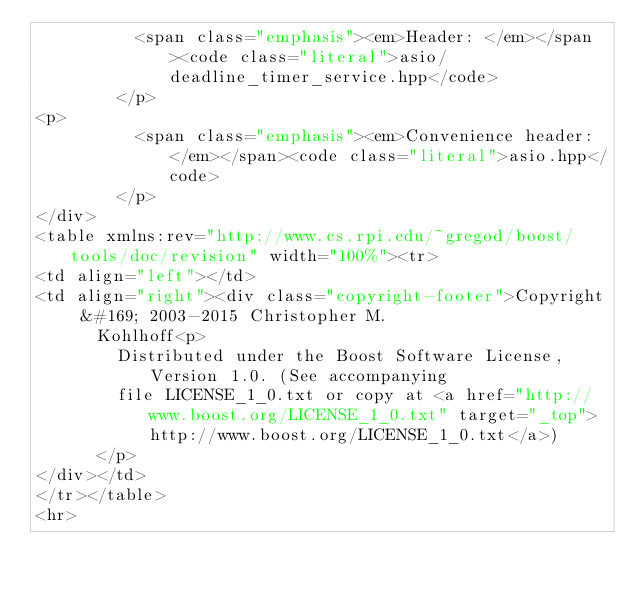<code> <loc_0><loc_0><loc_500><loc_500><_HTML_>          <span class="emphasis"><em>Header: </em></span><code class="literal">asio/deadline_timer_service.hpp</code>
        </p>
<p>
          <span class="emphasis"><em>Convenience header: </em></span><code class="literal">asio.hpp</code>
        </p>
</div>
<table xmlns:rev="http://www.cs.rpi.edu/~gregod/boost/tools/doc/revision" width="100%"><tr>
<td align="left"></td>
<td align="right"><div class="copyright-footer">Copyright &#169; 2003-2015 Christopher M.
      Kohlhoff<p>
        Distributed under the Boost Software License, Version 1.0. (See accompanying
        file LICENSE_1_0.txt or copy at <a href="http://www.boost.org/LICENSE_1_0.txt" target="_top">http://www.boost.org/LICENSE_1_0.txt</a>)
      </p>
</div></td>
</tr></table>
<hr></code> 